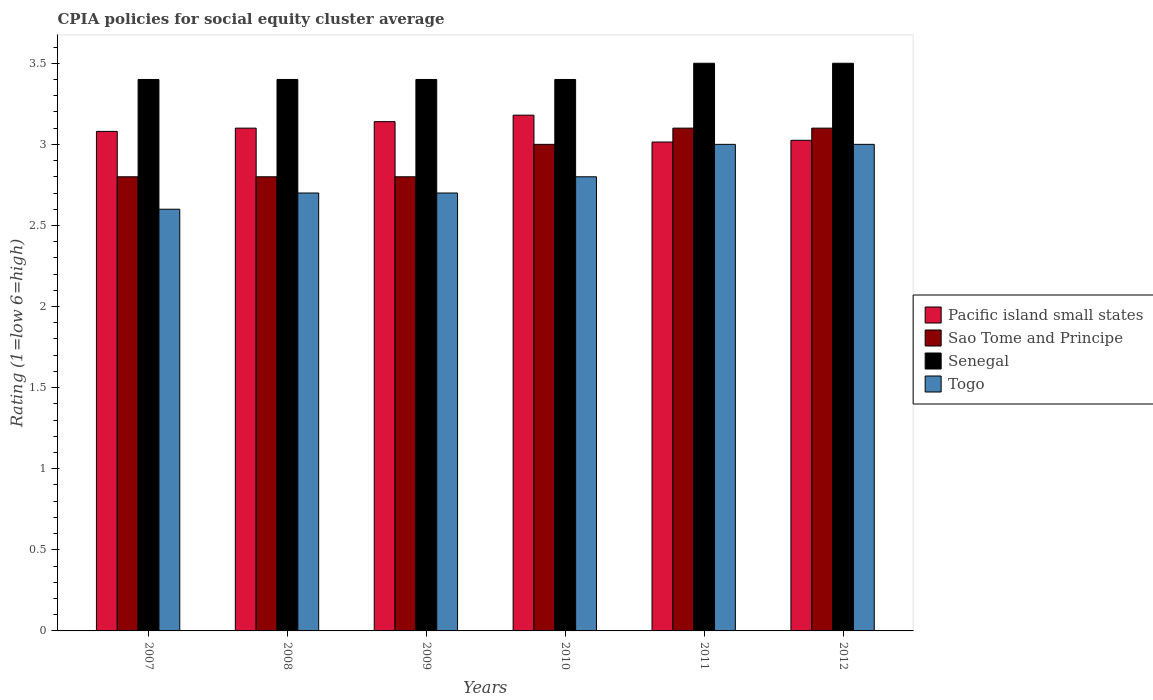How many groups of bars are there?
Provide a short and direct response. 6. How many bars are there on the 4th tick from the right?
Offer a terse response. 4. In how many cases, is the number of bars for a given year not equal to the number of legend labels?
Your answer should be compact. 0. What is the CPIA rating in Senegal in 2008?
Make the answer very short. 3.4. Across all years, what is the maximum CPIA rating in Pacific island small states?
Make the answer very short. 3.18. Across all years, what is the minimum CPIA rating in Senegal?
Offer a very short reply. 3.4. In which year was the CPIA rating in Sao Tome and Principe maximum?
Your response must be concise. 2011. In which year was the CPIA rating in Togo minimum?
Your answer should be compact. 2007. What is the total CPIA rating in Sao Tome and Principe in the graph?
Your answer should be very brief. 17.6. What is the difference between the CPIA rating in Sao Tome and Principe in 2007 and that in 2009?
Provide a succinct answer. 0. What is the difference between the CPIA rating in Senegal in 2008 and the CPIA rating in Sao Tome and Principe in 2012?
Offer a terse response. 0.3. What is the average CPIA rating in Sao Tome and Principe per year?
Your answer should be compact. 2.93. In the year 2011, what is the difference between the CPIA rating in Sao Tome and Principe and CPIA rating in Pacific island small states?
Offer a terse response. 0.09. In how many years, is the CPIA rating in Sao Tome and Principe greater than 3.5?
Your answer should be compact. 0. What is the ratio of the CPIA rating in Senegal in 2008 to that in 2012?
Provide a short and direct response. 0.97. Is the CPIA rating in Sao Tome and Principe in 2009 less than that in 2012?
Your response must be concise. Yes. Is the difference between the CPIA rating in Sao Tome and Principe in 2008 and 2011 greater than the difference between the CPIA rating in Pacific island small states in 2008 and 2011?
Offer a very short reply. No. What is the difference between the highest and the lowest CPIA rating in Pacific island small states?
Offer a terse response. 0.17. In how many years, is the CPIA rating in Sao Tome and Principe greater than the average CPIA rating in Sao Tome and Principe taken over all years?
Make the answer very short. 3. What does the 1st bar from the left in 2012 represents?
Make the answer very short. Pacific island small states. What does the 3rd bar from the right in 2007 represents?
Keep it short and to the point. Sao Tome and Principe. Is it the case that in every year, the sum of the CPIA rating in Senegal and CPIA rating in Togo is greater than the CPIA rating in Pacific island small states?
Ensure brevity in your answer.  Yes. How many bars are there?
Offer a very short reply. 24. Are all the bars in the graph horizontal?
Your answer should be very brief. No. How many years are there in the graph?
Give a very brief answer. 6. What is the difference between two consecutive major ticks on the Y-axis?
Give a very brief answer. 0.5. Does the graph contain any zero values?
Provide a short and direct response. No. How are the legend labels stacked?
Provide a succinct answer. Vertical. What is the title of the graph?
Give a very brief answer. CPIA policies for social equity cluster average. What is the Rating (1=low 6=high) in Pacific island small states in 2007?
Your answer should be compact. 3.08. What is the Rating (1=low 6=high) in Senegal in 2007?
Your answer should be compact. 3.4. What is the Rating (1=low 6=high) in Sao Tome and Principe in 2008?
Your answer should be compact. 2.8. What is the Rating (1=low 6=high) of Senegal in 2008?
Provide a succinct answer. 3.4. What is the Rating (1=low 6=high) in Togo in 2008?
Give a very brief answer. 2.7. What is the Rating (1=low 6=high) of Pacific island small states in 2009?
Keep it short and to the point. 3.14. What is the Rating (1=low 6=high) of Sao Tome and Principe in 2009?
Ensure brevity in your answer.  2.8. What is the Rating (1=low 6=high) of Pacific island small states in 2010?
Offer a very short reply. 3.18. What is the Rating (1=low 6=high) in Pacific island small states in 2011?
Keep it short and to the point. 3.01. What is the Rating (1=low 6=high) in Pacific island small states in 2012?
Ensure brevity in your answer.  3.02. What is the Rating (1=low 6=high) of Senegal in 2012?
Ensure brevity in your answer.  3.5. What is the Rating (1=low 6=high) in Togo in 2012?
Offer a terse response. 3. Across all years, what is the maximum Rating (1=low 6=high) in Pacific island small states?
Give a very brief answer. 3.18. Across all years, what is the maximum Rating (1=low 6=high) in Sao Tome and Principe?
Give a very brief answer. 3.1. Across all years, what is the maximum Rating (1=low 6=high) of Senegal?
Provide a short and direct response. 3.5. Across all years, what is the minimum Rating (1=low 6=high) of Pacific island small states?
Your response must be concise. 3.01. What is the total Rating (1=low 6=high) in Pacific island small states in the graph?
Your answer should be very brief. 18.54. What is the total Rating (1=low 6=high) of Senegal in the graph?
Ensure brevity in your answer.  20.6. What is the difference between the Rating (1=low 6=high) of Pacific island small states in 2007 and that in 2008?
Offer a very short reply. -0.02. What is the difference between the Rating (1=low 6=high) in Sao Tome and Principe in 2007 and that in 2008?
Your answer should be compact. 0. What is the difference between the Rating (1=low 6=high) of Senegal in 2007 and that in 2008?
Provide a short and direct response. 0. What is the difference between the Rating (1=low 6=high) of Togo in 2007 and that in 2008?
Your answer should be very brief. -0.1. What is the difference between the Rating (1=low 6=high) in Pacific island small states in 2007 and that in 2009?
Make the answer very short. -0.06. What is the difference between the Rating (1=low 6=high) in Sao Tome and Principe in 2007 and that in 2009?
Keep it short and to the point. 0. What is the difference between the Rating (1=low 6=high) of Senegal in 2007 and that in 2009?
Keep it short and to the point. 0. What is the difference between the Rating (1=low 6=high) in Togo in 2007 and that in 2010?
Your answer should be very brief. -0.2. What is the difference between the Rating (1=low 6=high) in Pacific island small states in 2007 and that in 2011?
Give a very brief answer. 0.07. What is the difference between the Rating (1=low 6=high) of Sao Tome and Principe in 2007 and that in 2011?
Give a very brief answer. -0.3. What is the difference between the Rating (1=low 6=high) in Togo in 2007 and that in 2011?
Provide a succinct answer. -0.4. What is the difference between the Rating (1=low 6=high) in Pacific island small states in 2007 and that in 2012?
Your response must be concise. 0.06. What is the difference between the Rating (1=low 6=high) of Sao Tome and Principe in 2007 and that in 2012?
Keep it short and to the point. -0.3. What is the difference between the Rating (1=low 6=high) in Senegal in 2007 and that in 2012?
Keep it short and to the point. -0.1. What is the difference between the Rating (1=low 6=high) in Togo in 2007 and that in 2012?
Keep it short and to the point. -0.4. What is the difference between the Rating (1=low 6=high) of Pacific island small states in 2008 and that in 2009?
Ensure brevity in your answer.  -0.04. What is the difference between the Rating (1=low 6=high) in Sao Tome and Principe in 2008 and that in 2009?
Offer a terse response. 0. What is the difference between the Rating (1=low 6=high) in Senegal in 2008 and that in 2009?
Provide a succinct answer. 0. What is the difference between the Rating (1=low 6=high) of Pacific island small states in 2008 and that in 2010?
Keep it short and to the point. -0.08. What is the difference between the Rating (1=low 6=high) in Sao Tome and Principe in 2008 and that in 2010?
Your response must be concise. -0.2. What is the difference between the Rating (1=low 6=high) in Togo in 2008 and that in 2010?
Your answer should be very brief. -0.1. What is the difference between the Rating (1=low 6=high) in Pacific island small states in 2008 and that in 2011?
Offer a very short reply. 0.09. What is the difference between the Rating (1=low 6=high) in Sao Tome and Principe in 2008 and that in 2011?
Provide a succinct answer. -0.3. What is the difference between the Rating (1=low 6=high) in Pacific island small states in 2008 and that in 2012?
Ensure brevity in your answer.  0.07. What is the difference between the Rating (1=low 6=high) of Togo in 2008 and that in 2012?
Make the answer very short. -0.3. What is the difference between the Rating (1=low 6=high) in Pacific island small states in 2009 and that in 2010?
Make the answer very short. -0.04. What is the difference between the Rating (1=low 6=high) of Sao Tome and Principe in 2009 and that in 2010?
Your answer should be very brief. -0.2. What is the difference between the Rating (1=low 6=high) of Pacific island small states in 2009 and that in 2011?
Your response must be concise. 0.13. What is the difference between the Rating (1=low 6=high) in Sao Tome and Principe in 2009 and that in 2011?
Make the answer very short. -0.3. What is the difference between the Rating (1=low 6=high) of Pacific island small states in 2009 and that in 2012?
Provide a succinct answer. 0.12. What is the difference between the Rating (1=low 6=high) of Sao Tome and Principe in 2009 and that in 2012?
Provide a short and direct response. -0.3. What is the difference between the Rating (1=low 6=high) in Pacific island small states in 2010 and that in 2011?
Offer a terse response. 0.17. What is the difference between the Rating (1=low 6=high) in Senegal in 2010 and that in 2011?
Offer a terse response. -0.1. What is the difference between the Rating (1=low 6=high) in Togo in 2010 and that in 2011?
Your answer should be compact. -0.2. What is the difference between the Rating (1=low 6=high) of Pacific island small states in 2010 and that in 2012?
Give a very brief answer. 0.15. What is the difference between the Rating (1=low 6=high) of Togo in 2010 and that in 2012?
Make the answer very short. -0.2. What is the difference between the Rating (1=low 6=high) in Pacific island small states in 2011 and that in 2012?
Your answer should be compact. -0.01. What is the difference between the Rating (1=low 6=high) in Senegal in 2011 and that in 2012?
Provide a succinct answer. 0. What is the difference between the Rating (1=low 6=high) of Pacific island small states in 2007 and the Rating (1=low 6=high) of Sao Tome and Principe in 2008?
Provide a succinct answer. 0.28. What is the difference between the Rating (1=low 6=high) in Pacific island small states in 2007 and the Rating (1=low 6=high) in Senegal in 2008?
Provide a succinct answer. -0.32. What is the difference between the Rating (1=low 6=high) of Pacific island small states in 2007 and the Rating (1=low 6=high) of Togo in 2008?
Offer a terse response. 0.38. What is the difference between the Rating (1=low 6=high) in Pacific island small states in 2007 and the Rating (1=low 6=high) in Sao Tome and Principe in 2009?
Offer a very short reply. 0.28. What is the difference between the Rating (1=low 6=high) of Pacific island small states in 2007 and the Rating (1=low 6=high) of Senegal in 2009?
Offer a terse response. -0.32. What is the difference between the Rating (1=low 6=high) of Pacific island small states in 2007 and the Rating (1=low 6=high) of Togo in 2009?
Your response must be concise. 0.38. What is the difference between the Rating (1=low 6=high) in Senegal in 2007 and the Rating (1=low 6=high) in Togo in 2009?
Provide a short and direct response. 0.7. What is the difference between the Rating (1=low 6=high) in Pacific island small states in 2007 and the Rating (1=low 6=high) in Sao Tome and Principe in 2010?
Ensure brevity in your answer.  0.08. What is the difference between the Rating (1=low 6=high) of Pacific island small states in 2007 and the Rating (1=low 6=high) of Senegal in 2010?
Give a very brief answer. -0.32. What is the difference between the Rating (1=low 6=high) of Pacific island small states in 2007 and the Rating (1=low 6=high) of Togo in 2010?
Offer a very short reply. 0.28. What is the difference between the Rating (1=low 6=high) of Sao Tome and Principe in 2007 and the Rating (1=low 6=high) of Senegal in 2010?
Your answer should be very brief. -0.6. What is the difference between the Rating (1=low 6=high) in Sao Tome and Principe in 2007 and the Rating (1=low 6=high) in Togo in 2010?
Your answer should be very brief. 0. What is the difference between the Rating (1=low 6=high) of Pacific island small states in 2007 and the Rating (1=low 6=high) of Sao Tome and Principe in 2011?
Offer a terse response. -0.02. What is the difference between the Rating (1=low 6=high) of Pacific island small states in 2007 and the Rating (1=low 6=high) of Senegal in 2011?
Your answer should be compact. -0.42. What is the difference between the Rating (1=low 6=high) of Sao Tome and Principe in 2007 and the Rating (1=low 6=high) of Senegal in 2011?
Offer a terse response. -0.7. What is the difference between the Rating (1=low 6=high) of Sao Tome and Principe in 2007 and the Rating (1=low 6=high) of Togo in 2011?
Your answer should be compact. -0.2. What is the difference between the Rating (1=low 6=high) in Senegal in 2007 and the Rating (1=low 6=high) in Togo in 2011?
Give a very brief answer. 0.4. What is the difference between the Rating (1=low 6=high) in Pacific island small states in 2007 and the Rating (1=low 6=high) in Sao Tome and Principe in 2012?
Your answer should be very brief. -0.02. What is the difference between the Rating (1=low 6=high) of Pacific island small states in 2007 and the Rating (1=low 6=high) of Senegal in 2012?
Ensure brevity in your answer.  -0.42. What is the difference between the Rating (1=low 6=high) of Pacific island small states in 2007 and the Rating (1=low 6=high) of Togo in 2012?
Keep it short and to the point. 0.08. What is the difference between the Rating (1=low 6=high) in Senegal in 2007 and the Rating (1=low 6=high) in Togo in 2012?
Provide a succinct answer. 0.4. What is the difference between the Rating (1=low 6=high) in Pacific island small states in 2008 and the Rating (1=low 6=high) in Togo in 2009?
Give a very brief answer. 0.4. What is the difference between the Rating (1=low 6=high) in Sao Tome and Principe in 2008 and the Rating (1=low 6=high) in Senegal in 2009?
Provide a succinct answer. -0.6. What is the difference between the Rating (1=low 6=high) in Sao Tome and Principe in 2008 and the Rating (1=low 6=high) in Togo in 2009?
Offer a very short reply. 0.1. What is the difference between the Rating (1=low 6=high) in Pacific island small states in 2008 and the Rating (1=low 6=high) in Togo in 2010?
Provide a short and direct response. 0.3. What is the difference between the Rating (1=low 6=high) in Senegal in 2008 and the Rating (1=low 6=high) in Togo in 2010?
Give a very brief answer. 0.6. What is the difference between the Rating (1=low 6=high) of Pacific island small states in 2008 and the Rating (1=low 6=high) of Togo in 2011?
Offer a very short reply. 0.1. What is the difference between the Rating (1=low 6=high) in Sao Tome and Principe in 2008 and the Rating (1=low 6=high) in Senegal in 2011?
Offer a terse response. -0.7. What is the difference between the Rating (1=low 6=high) of Sao Tome and Principe in 2008 and the Rating (1=low 6=high) of Togo in 2011?
Offer a very short reply. -0.2. What is the difference between the Rating (1=low 6=high) of Pacific island small states in 2008 and the Rating (1=low 6=high) of Sao Tome and Principe in 2012?
Ensure brevity in your answer.  0. What is the difference between the Rating (1=low 6=high) of Pacific island small states in 2008 and the Rating (1=low 6=high) of Senegal in 2012?
Your answer should be very brief. -0.4. What is the difference between the Rating (1=low 6=high) in Pacific island small states in 2008 and the Rating (1=low 6=high) in Togo in 2012?
Offer a terse response. 0.1. What is the difference between the Rating (1=low 6=high) of Sao Tome and Principe in 2008 and the Rating (1=low 6=high) of Senegal in 2012?
Offer a terse response. -0.7. What is the difference between the Rating (1=low 6=high) of Sao Tome and Principe in 2008 and the Rating (1=low 6=high) of Togo in 2012?
Provide a succinct answer. -0.2. What is the difference between the Rating (1=low 6=high) of Pacific island small states in 2009 and the Rating (1=low 6=high) of Sao Tome and Principe in 2010?
Make the answer very short. 0.14. What is the difference between the Rating (1=low 6=high) of Pacific island small states in 2009 and the Rating (1=low 6=high) of Senegal in 2010?
Your answer should be very brief. -0.26. What is the difference between the Rating (1=low 6=high) in Pacific island small states in 2009 and the Rating (1=low 6=high) in Togo in 2010?
Give a very brief answer. 0.34. What is the difference between the Rating (1=low 6=high) in Sao Tome and Principe in 2009 and the Rating (1=low 6=high) in Togo in 2010?
Make the answer very short. 0. What is the difference between the Rating (1=low 6=high) in Pacific island small states in 2009 and the Rating (1=low 6=high) in Senegal in 2011?
Provide a succinct answer. -0.36. What is the difference between the Rating (1=low 6=high) in Pacific island small states in 2009 and the Rating (1=low 6=high) in Togo in 2011?
Keep it short and to the point. 0.14. What is the difference between the Rating (1=low 6=high) in Senegal in 2009 and the Rating (1=low 6=high) in Togo in 2011?
Your answer should be very brief. 0.4. What is the difference between the Rating (1=low 6=high) of Pacific island small states in 2009 and the Rating (1=low 6=high) of Senegal in 2012?
Ensure brevity in your answer.  -0.36. What is the difference between the Rating (1=low 6=high) of Pacific island small states in 2009 and the Rating (1=low 6=high) of Togo in 2012?
Keep it short and to the point. 0.14. What is the difference between the Rating (1=low 6=high) of Sao Tome and Principe in 2009 and the Rating (1=low 6=high) of Senegal in 2012?
Make the answer very short. -0.7. What is the difference between the Rating (1=low 6=high) of Senegal in 2009 and the Rating (1=low 6=high) of Togo in 2012?
Provide a short and direct response. 0.4. What is the difference between the Rating (1=low 6=high) of Pacific island small states in 2010 and the Rating (1=low 6=high) of Senegal in 2011?
Keep it short and to the point. -0.32. What is the difference between the Rating (1=low 6=high) of Pacific island small states in 2010 and the Rating (1=low 6=high) of Togo in 2011?
Your answer should be compact. 0.18. What is the difference between the Rating (1=low 6=high) of Pacific island small states in 2010 and the Rating (1=low 6=high) of Sao Tome and Principe in 2012?
Provide a short and direct response. 0.08. What is the difference between the Rating (1=low 6=high) of Pacific island small states in 2010 and the Rating (1=low 6=high) of Senegal in 2012?
Your response must be concise. -0.32. What is the difference between the Rating (1=low 6=high) of Pacific island small states in 2010 and the Rating (1=low 6=high) of Togo in 2012?
Ensure brevity in your answer.  0.18. What is the difference between the Rating (1=low 6=high) of Sao Tome and Principe in 2010 and the Rating (1=low 6=high) of Togo in 2012?
Offer a terse response. 0. What is the difference between the Rating (1=low 6=high) of Senegal in 2010 and the Rating (1=low 6=high) of Togo in 2012?
Make the answer very short. 0.4. What is the difference between the Rating (1=low 6=high) in Pacific island small states in 2011 and the Rating (1=low 6=high) in Sao Tome and Principe in 2012?
Ensure brevity in your answer.  -0.09. What is the difference between the Rating (1=low 6=high) of Pacific island small states in 2011 and the Rating (1=low 6=high) of Senegal in 2012?
Your response must be concise. -0.49. What is the difference between the Rating (1=low 6=high) of Pacific island small states in 2011 and the Rating (1=low 6=high) of Togo in 2012?
Make the answer very short. 0.01. What is the difference between the Rating (1=low 6=high) of Sao Tome and Principe in 2011 and the Rating (1=low 6=high) of Senegal in 2012?
Keep it short and to the point. -0.4. What is the average Rating (1=low 6=high) in Pacific island small states per year?
Give a very brief answer. 3.09. What is the average Rating (1=low 6=high) in Sao Tome and Principe per year?
Offer a terse response. 2.93. What is the average Rating (1=low 6=high) in Senegal per year?
Your response must be concise. 3.43. What is the average Rating (1=low 6=high) in Togo per year?
Your answer should be compact. 2.8. In the year 2007, what is the difference between the Rating (1=low 6=high) in Pacific island small states and Rating (1=low 6=high) in Sao Tome and Principe?
Keep it short and to the point. 0.28. In the year 2007, what is the difference between the Rating (1=low 6=high) of Pacific island small states and Rating (1=low 6=high) of Senegal?
Keep it short and to the point. -0.32. In the year 2007, what is the difference between the Rating (1=low 6=high) of Pacific island small states and Rating (1=low 6=high) of Togo?
Ensure brevity in your answer.  0.48. In the year 2007, what is the difference between the Rating (1=low 6=high) of Sao Tome and Principe and Rating (1=low 6=high) of Togo?
Offer a terse response. 0.2. In the year 2007, what is the difference between the Rating (1=low 6=high) of Senegal and Rating (1=low 6=high) of Togo?
Offer a very short reply. 0.8. In the year 2008, what is the difference between the Rating (1=low 6=high) of Pacific island small states and Rating (1=low 6=high) of Senegal?
Provide a short and direct response. -0.3. In the year 2008, what is the difference between the Rating (1=low 6=high) of Sao Tome and Principe and Rating (1=low 6=high) of Senegal?
Give a very brief answer. -0.6. In the year 2008, what is the difference between the Rating (1=low 6=high) in Sao Tome and Principe and Rating (1=low 6=high) in Togo?
Make the answer very short. 0.1. In the year 2008, what is the difference between the Rating (1=low 6=high) in Senegal and Rating (1=low 6=high) in Togo?
Make the answer very short. 0.7. In the year 2009, what is the difference between the Rating (1=low 6=high) of Pacific island small states and Rating (1=low 6=high) of Sao Tome and Principe?
Provide a succinct answer. 0.34. In the year 2009, what is the difference between the Rating (1=low 6=high) in Pacific island small states and Rating (1=low 6=high) in Senegal?
Make the answer very short. -0.26. In the year 2009, what is the difference between the Rating (1=low 6=high) in Pacific island small states and Rating (1=low 6=high) in Togo?
Offer a very short reply. 0.44. In the year 2009, what is the difference between the Rating (1=low 6=high) in Sao Tome and Principe and Rating (1=low 6=high) in Senegal?
Make the answer very short. -0.6. In the year 2010, what is the difference between the Rating (1=low 6=high) in Pacific island small states and Rating (1=low 6=high) in Sao Tome and Principe?
Your answer should be compact. 0.18. In the year 2010, what is the difference between the Rating (1=low 6=high) in Pacific island small states and Rating (1=low 6=high) in Senegal?
Your answer should be compact. -0.22. In the year 2010, what is the difference between the Rating (1=low 6=high) of Pacific island small states and Rating (1=low 6=high) of Togo?
Your answer should be compact. 0.38. In the year 2010, what is the difference between the Rating (1=low 6=high) of Sao Tome and Principe and Rating (1=low 6=high) of Togo?
Your answer should be compact. 0.2. In the year 2010, what is the difference between the Rating (1=low 6=high) in Senegal and Rating (1=low 6=high) in Togo?
Your answer should be compact. 0.6. In the year 2011, what is the difference between the Rating (1=low 6=high) in Pacific island small states and Rating (1=low 6=high) in Sao Tome and Principe?
Provide a succinct answer. -0.09. In the year 2011, what is the difference between the Rating (1=low 6=high) in Pacific island small states and Rating (1=low 6=high) in Senegal?
Your answer should be very brief. -0.49. In the year 2011, what is the difference between the Rating (1=low 6=high) in Pacific island small states and Rating (1=low 6=high) in Togo?
Your answer should be very brief. 0.01. In the year 2012, what is the difference between the Rating (1=low 6=high) in Pacific island small states and Rating (1=low 6=high) in Sao Tome and Principe?
Keep it short and to the point. -0.07. In the year 2012, what is the difference between the Rating (1=low 6=high) of Pacific island small states and Rating (1=low 6=high) of Senegal?
Keep it short and to the point. -0.47. In the year 2012, what is the difference between the Rating (1=low 6=high) of Pacific island small states and Rating (1=low 6=high) of Togo?
Offer a terse response. 0.03. In the year 2012, what is the difference between the Rating (1=low 6=high) in Sao Tome and Principe and Rating (1=low 6=high) in Senegal?
Your answer should be very brief. -0.4. In the year 2012, what is the difference between the Rating (1=low 6=high) in Senegal and Rating (1=low 6=high) in Togo?
Keep it short and to the point. 0.5. What is the ratio of the Rating (1=low 6=high) of Sao Tome and Principe in 2007 to that in 2008?
Provide a succinct answer. 1. What is the ratio of the Rating (1=low 6=high) of Senegal in 2007 to that in 2008?
Give a very brief answer. 1. What is the ratio of the Rating (1=low 6=high) of Pacific island small states in 2007 to that in 2009?
Provide a succinct answer. 0.98. What is the ratio of the Rating (1=low 6=high) in Sao Tome and Principe in 2007 to that in 2009?
Your answer should be compact. 1. What is the ratio of the Rating (1=low 6=high) of Senegal in 2007 to that in 2009?
Provide a succinct answer. 1. What is the ratio of the Rating (1=low 6=high) in Togo in 2007 to that in 2009?
Offer a terse response. 0.96. What is the ratio of the Rating (1=low 6=high) in Pacific island small states in 2007 to that in 2010?
Make the answer very short. 0.97. What is the ratio of the Rating (1=low 6=high) in Togo in 2007 to that in 2010?
Your answer should be very brief. 0.93. What is the ratio of the Rating (1=low 6=high) in Pacific island small states in 2007 to that in 2011?
Offer a very short reply. 1.02. What is the ratio of the Rating (1=low 6=high) in Sao Tome and Principe in 2007 to that in 2011?
Your response must be concise. 0.9. What is the ratio of the Rating (1=low 6=high) in Senegal in 2007 to that in 2011?
Your response must be concise. 0.97. What is the ratio of the Rating (1=low 6=high) of Togo in 2007 to that in 2011?
Make the answer very short. 0.87. What is the ratio of the Rating (1=low 6=high) of Pacific island small states in 2007 to that in 2012?
Give a very brief answer. 1.02. What is the ratio of the Rating (1=low 6=high) in Sao Tome and Principe in 2007 to that in 2012?
Your answer should be very brief. 0.9. What is the ratio of the Rating (1=low 6=high) of Senegal in 2007 to that in 2012?
Offer a very short reply. 0.97. What is the ratio of the Rating (1=low 6=high) in Togo in 2007 to that in 2012?
Your answer should be compact. 0.87. What is the ratio of the Rating (1=low 6=high) in Pacific island small states in 2008 to that in 2009?
Provide a succinct answer. 0.99. What is the ratio of the Rating (1=low 6=high) in Senegal in 2008 to that in 2009?
Offer a terse response. 1. What is the ratio of the Rating (1=low 6=high) in Togo in 2008 to that in 2009?
Give a very brief answer. 1. What is the ratio of the Rating (1=low 6=high) in Pacific island small states in 2008 to that in 2010?
Keep it short and to the point. 0.97. What is the ratio of the Rating (1=low 6=high) in Pacific island small states in 2008 to that in 2011?
Your answer should be compact. 1.03. What is the ratio of the Rating (1=low 6=high) of Sao Tome and Principe in 2008 to that in 2011?
Provide a succinct answer. 0.9. What is the ratio of the Rating (1=low 6=high) in Senegal in 2008 to that in 2011?
Offer a very short reply. 0.97. What is the ratio of the Rating (1=low 6=high) in Pacific island small states in 2008 to that in 2012?
Offer a terse response. 1.02. What is the ratio of the Rating (1=low 6=high) in Sao Tome and Principe in 2008 to that in 2012?
Provide a short and direct response. 0.9. What is the ratio of the Rating (1=low 6=high) in Senegal in 2008 to that in 2012?
Offer a terse response. 0.97. What is the ratio of the Rating (1=low 6=high) of Pacific island small states in 2009 to that in 2010?
Ensure brevity in your answer.  0.99. What is the ratio of the Rating (1=low 6=high) of Sao Tome and Principe in 2009 to that in 2010?
Your answer should be compact. 0.93. What is the ratio of the Rating (1=low 6=high) in Senegal in 2009 to that in 2010?
Ensure brevity in your answer.  1. What is the ratio of the Rating (1=low 6=high) in Togo in 2009 to that in 2010?
Your answer should be very brief. 0.96. What is the ratio of the Rating (1=low 6=high) of Pacific island small states in 2009 to that in 2011?
Provide a succinct answer. 1.04. What is the ratio of the Rating (1=low 6=high) in Sao Tome and Principe in 2009 to that in 2011?
Provide a short and direct response. 0.9. What is the ratio of the Rating (1=low 6=high) in Senegal in 2009 to that in 2011?
Make the answer very short. 0.97. What is the ratio of the Rating (1=low 6=high) of Pacific island small states in 2009 to that in 2012?
Offer a terse response. 1.04. What is the ratio of the Rating (1=low 6=high) of Sao Tome and Principe in 2009 to that in 2012?
Provide a short and direct response. 0.9. What is the ratio of the Rating (1=low 6=high) of Senegal in 2009 to that in 2012?
Ensure brevity in your answer.  0.97. What is the ratio of the Rating (1=low 6=high) of Togo in 2009 to that in 2012?
Offer a very short reply. 0.9. What is the ratio of the Rating (1=low 6=high) of Pacific island small states in 2010 to that in 2011?
Make the answer very short. 1.05. What is the ratio of the Rating (1=low 6=high) in Senegal in 2010 to that in 2011?
Make the answer very short. 0.97. What is the ratio of the Rating (1=low 6=high) of Togo in 2010 to that in 2011?
Provide a succinct answer. 0.93. What is the ratio of the Rating (1=low 6=high) in Pacific island small states in 2010 to that in 2012?
Ensure brevity in your answer.  1.05. What is the ratio of the Rating (1=low 6=high) in Senegal in 2010 to that in 2012?
Provide a short and direct response. 0.97. What is the ratio of the Rating (1=low 6=high) of Togo in 2011 to that in 2012?
Ensure brevity in your answer.  1. What is the difference between the highest and the second highest Rating (1=low 6=high) of Senegal?
Your answer should be very brief. 0. What is the difference between the highest and the second highest Rating (1=low 6=high) of Togo?
Your answer should be very brief. 0. What is the difference between the highest and the lowest Rating (1=low 6=high) in Pacific island small states?
Give a very brief answer. 0.17. What is the difference between the highest and the lowest Rating (1=low 6=high) of Sao Tome and Principe?
Keep it short and to the point. 0.3. What is the difference between the highest and the lowest Rating (1=low 6=high) of Senegal?
Provide a short and direct response. 0.1. 